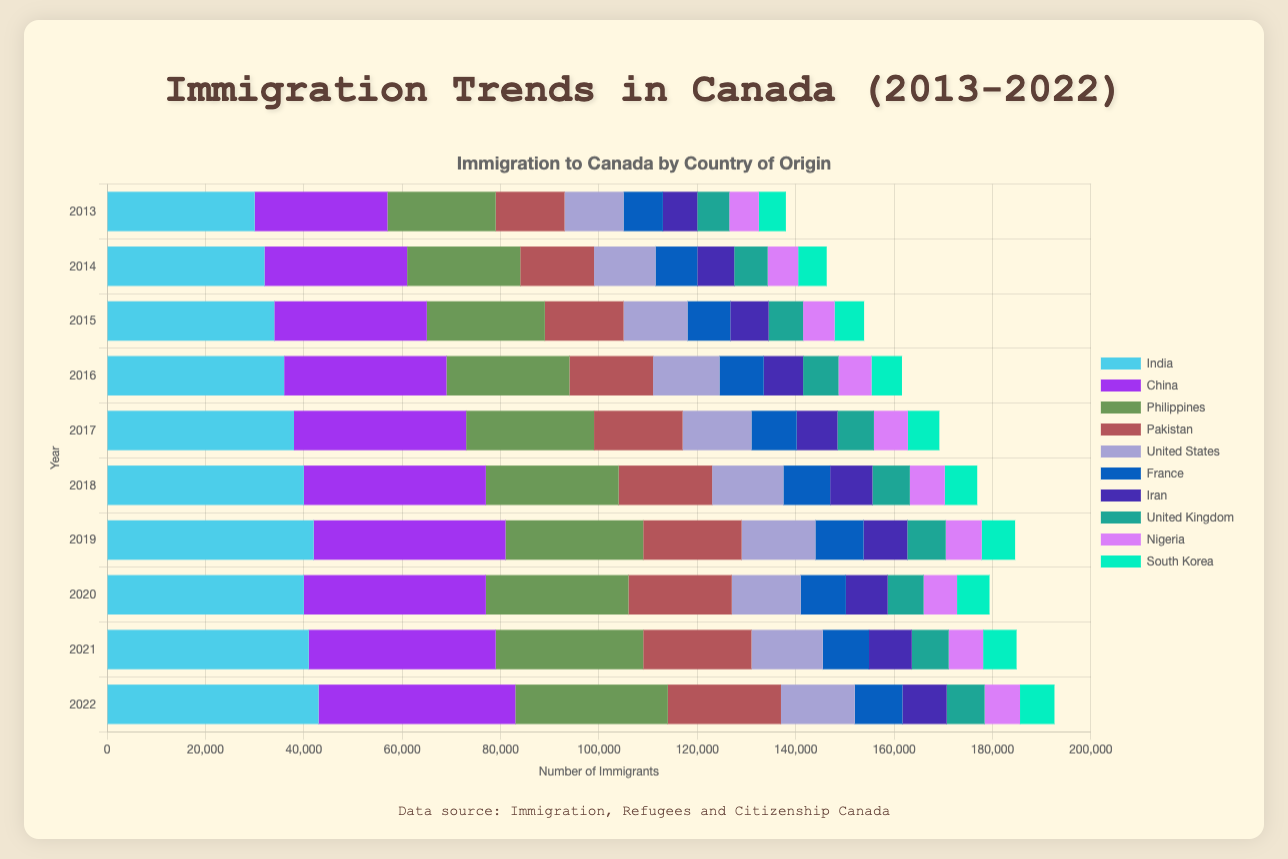Which country saw the highest increase in immigration to Canada from 2013 to 2022? To determine the country with the highest increase, we need to subtract the number of immigrants in 2013 from the number of immigrants in 2022 for each country. India's increase is 43000 - 30000 = 13000, China's is 40000 - 27000 = 13000, Philippines' is 31000 - 22000 = 9000, Pakistan's is 23000 - 14000 = 9000, United States' is 15000 - 12000 = 3000, France's is 9700 - 8000 = 1700, Iran's is 9000 - 7000 = 2000, United Kingdom's is 7700 - 6500 = 1200, Nigeria's is 7200 - 6000 = 1200, and South Korea's is 7000 - 5500 = 1500. India and China both saw the highest increase of 13000.
Answer: India and China How did immigration from the Philippines change from 2013 to 2020? To assess the change, we compare the number of immigrants from the Philippines in 2013 to that in 2020. In 2013, it was 22000 and in 2020, it was 29000. The difference is 29000 - 22000 = 7000, showing an increase.
Answer: Increased by 7000 Which year saw the highest number of immigrants from China? Looking at the bar lengths associated with China across the years, the longest bar representing the year with the highest immigration from China is in 2022 with 40000 immigrants.
Answer: 2022 Which three countries had the least immigration numbers to Canada in 2015? To find the three countries with the least immigration in 2015, we look for the three shortest bars in that year. They are the United Kingdom (7000), Nigeria (6400), and South Korea (6000).
Answer: United Kingdom, Nigeria, South Korea In which years did immigration from the United States remain unchanged? By examining the length of the bars for the United States across the years, we see the bars for 2020 (14000) and 2017 (14000) are of equal lengths indicating the same number of immigrants from the United States in these years.
Answer: 2017 and 2020 What is the average number of immigrants from Iran from 2013 to 2022? To find the average, we sum up the immigrant counts from Iran for each year and divide by the number of years. The sums are 7000 + 7500 + 7800 + 8000 + 8300 + 8600 + 8900 + 8500 + 8700 + 9000 = 82300. Then, 82300 / 10 = 8230.
Answer: 8230 Compare the immigration numbers from India and the Philippines in 2019. Which was higher and by how much? We first check the immigrant numbers for both countries in 2019: India had 42000 and the Philippines had 28000. The difference is 42000 - 28000 = 14000, so India had a higher number by 14000.
Answer: India by 14000 Which country's immigration numbers showed the least variation over the decade? To identify the country with the least variation, we observe the annual immigration numbers for each country. South Korea’s numbers are relatively stable, ranging between 5500 and 7000, with fluctuations being minimal compared to other countries.
Answer: South Korea How did the total immigration to Canada from the top 3 contributing countries (India, China, and Philippines) change from 2013 to 2022? Summing up the immigration numbers for India, China, and the Philippines in 2013: 30000 (India) + 27000 (China) + 22000 (Philippines) = 79000, and in 2022: 43000 (India) + 40000 (China) + 31000 (Philippines) = 114000. The difference is 114000 - 79000 = 35000, showing an increase.
Answer: Increased by 35000 